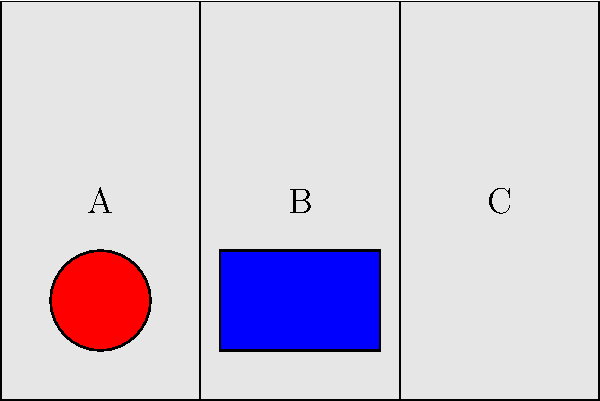As a Tuareg camel herder preparing for a nomadic journey, you need to efficiently pack a camel saddle with three items: a round water container (1), a rectangular food box (2), and a triangular tent (3). The saddle has three compartments (A, B, and C) as shown. Which arrangement of items in the compartments would distribute the weight most evenly across the saddle? To distribute the weight evenly across the camel saddle, we need to consider the shape and size of each item and how they fit into the compartments:

1. The round water container (1) is small and compact. It fits well in compartment A, which is the narrowest.

2. The rectangular food box (2) is wider and fits perfectly in compartment B, which is of medium width.

3. The triangular tent (3) has an irregular shape and would be best placed in compartment C, which is the widest and can accommodate its unique form.

By placing the items in this order (1 in A, 2 in B, 3 in C), we achieve the following benefits:

a) Each item is securely fitted in its compartment, reducing movement during travel.
b) The weight is distributed across all three compartments, balancing the load on the camel's back.
c) The arrangement makes efficient use of the available space, with each item's shape complementing its assigned compartment.

This configuration ensures that no single part of the saddle bears a disproportionate amount of weight, which is crucial for the camel's comfort and endurance during long journeys across the desert.
Answer: 1 in A, 2 in B, 3 in C 